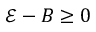<formula> <loc_0><loc_0><loc_500><loc_500>\mathcal { E } - B \geq 0</formula> 